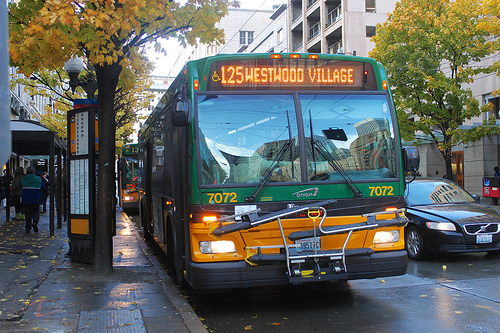Can you describe the weather as seen in the image and its impact on the urban environment? The image depicts a rainy day with wet streets reflecting the city's lights. The damp weather has likely enhanced the reflective quality of the bus and made the colors of the trees appear more vibrant, creating a vivid autumn urban scene. 